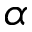<formula> <loc_0><loc_0><loc_500><loc_500>\alpha</formula> 